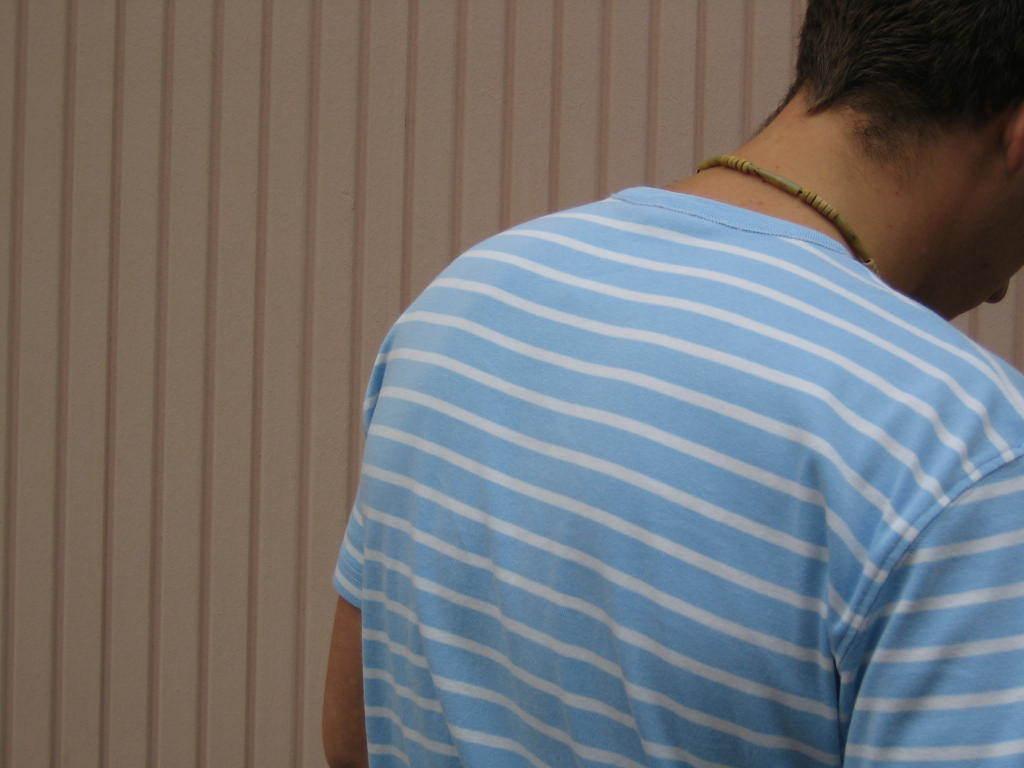In one or two sentences, can you explain what this image depicts? In this image I can see the person wearing the white and blue color dress and I can see the wall in the back. 